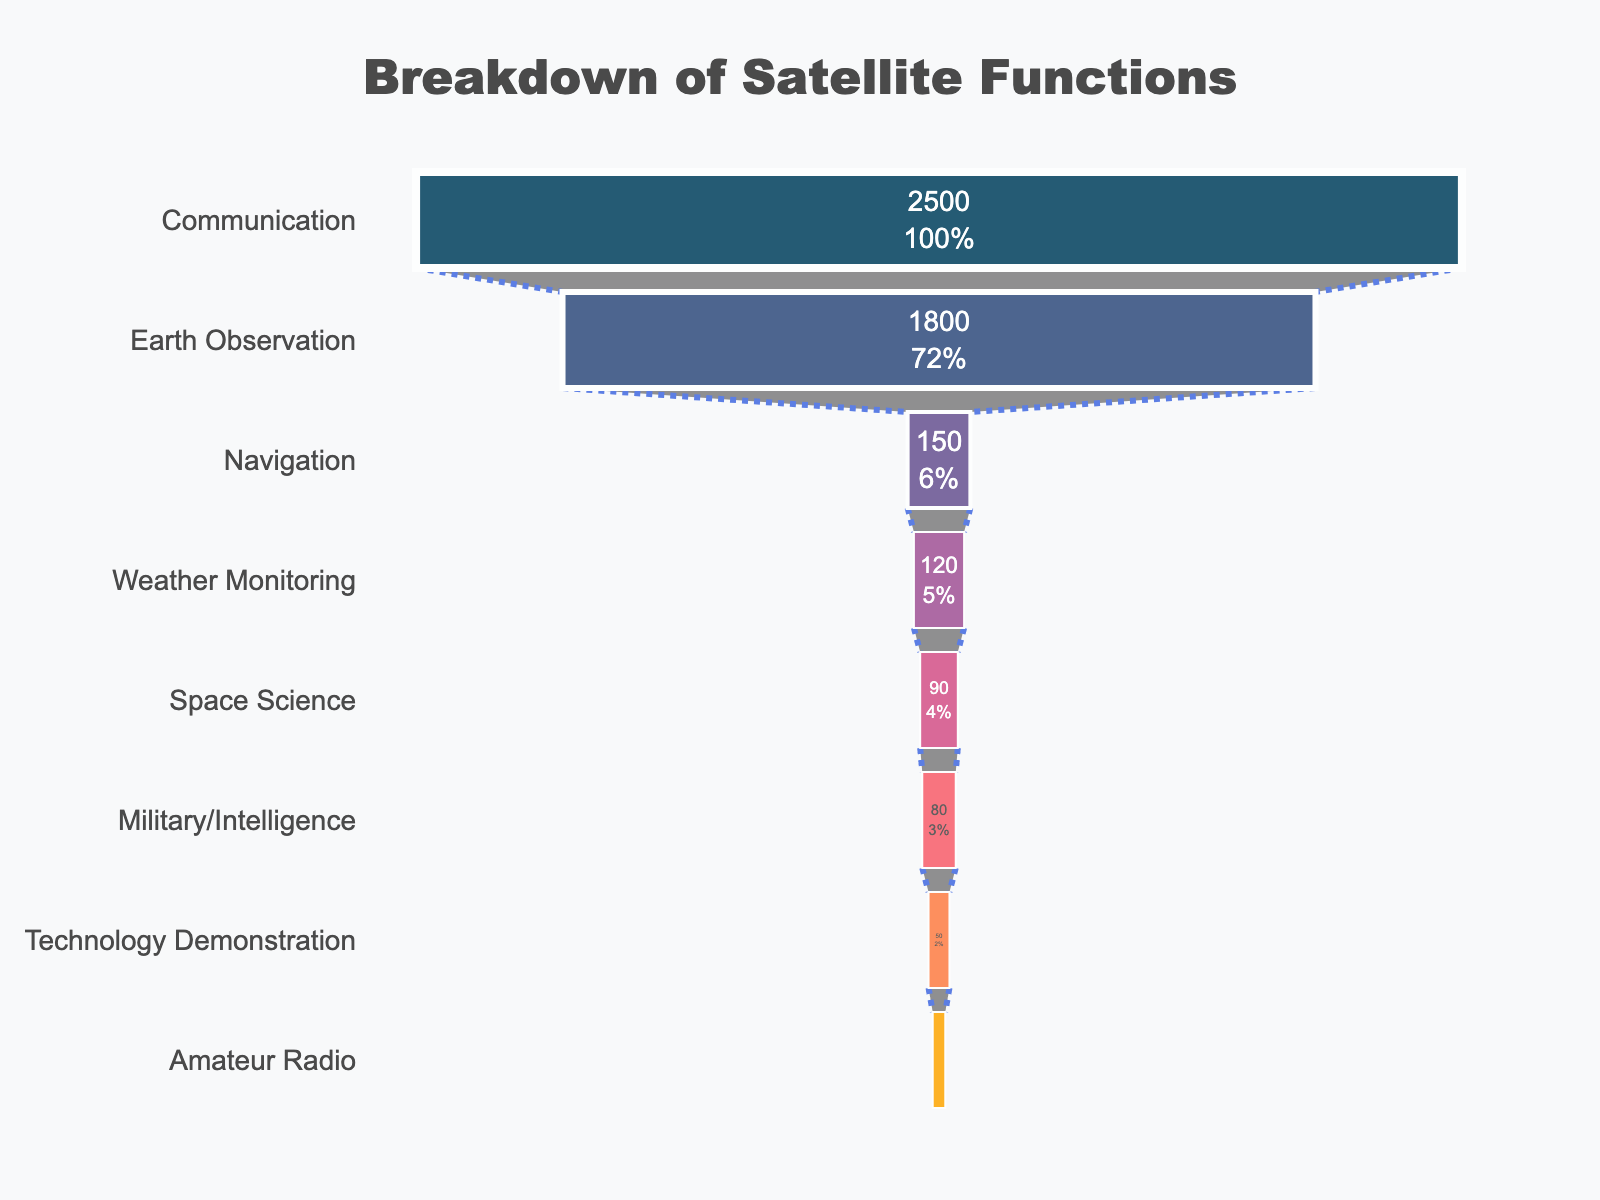What's the title of the figure? The title is usually at the top of the chart and provides a quick overview of what the chart is about. In this chart, the title is positioned at the top center of the figure.
Answer: Breakdown of Satellite Functions How many categories of satellite functions are displayed in the chart? The number of satellite categories corresponds to the number of distinct y-axis labels on the funnel chart.
Answer: 8 Which satellite function has the highest number of satellites? Look at the y-axis and identify which category has the longest corresponding bar on the funnel chart.
Answer: Communication What is the percentage of Communication satellites compared to the initial total? The funnel chart shows a combination of numbers and percentages within the bars. The percentage within the Communication category indicates its proportion relative to the total number of satellites.
Answer: 43.1% What's the total number of satellites across all categories? Sum the number of satellites for all categories. Communication (2500) + Earth Observation (1800) + Navigation (150) + Weather Monitoring (120) + Space Science (90) + Military/Intelligence (80) + Technology Demonstration (50) + Amateur Radio (30) = 4820.
Answer: 4820 How many more satellites are used for Earth Observation than for Military/Intelligence? Subtract the number of Military/Intelligence satellites from the number of Earth Observation satellites. 1800 (Earth Observation) - 80 (Military/Intelligence) = 1720.
Answer: 1720 What is the combined number of satellites used for Navigation and Weather Monitoring? Sum the number of Navigation satellites and Weather Monitoring satellites. 150 (Navigation) + 120 (Weather Monitoring) = 270.
Answer: 270 Which category has the least number of satellites, and what is that number? Identify the smallest bar on the funnel chart and its value.
Answer: Amateur Radio, 30 How does the number of Technology Demonstration satellites compare to the number of Weather Monitoring satellites? Compare the lengths of the bars or directly compare the provided satellite counts. Technology Demonstration (50) is less than Weather Monitoring (120).
Answer: Less What is the difference in the number of satellites between the top two categories? Subtract the number of Earth Observation satellites from the number of Communication satellites. 2500 (Communication) - 1800 (Earth Observation) = 700.
Answer: 700 